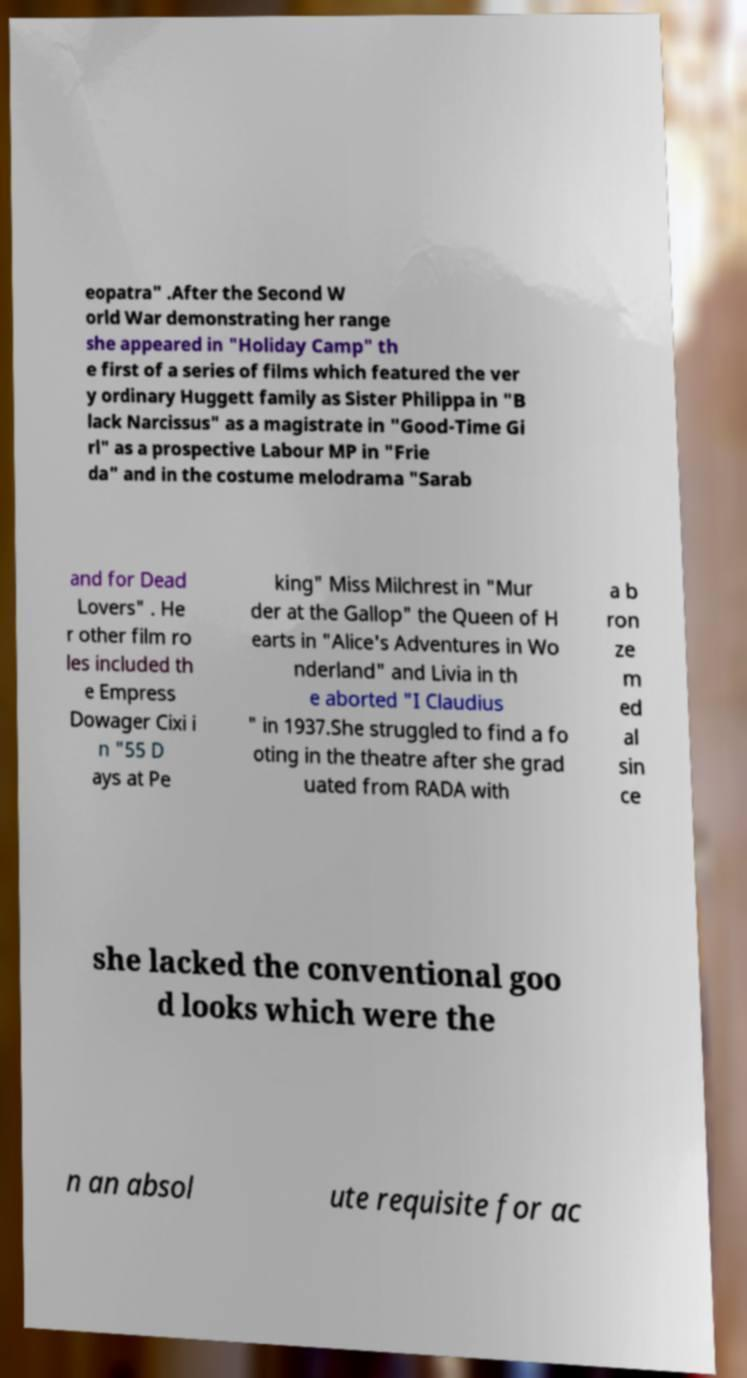Please identify and transcribe the text found in this image. eopatra" .After the Second W orld War demonstrating her range she appeared in "Holiday Camp" th e first of a series of films which featured the ver y ordinary Huggett family as Sister Philippa in "B lack Narcissus" as a magistrate in "Good-Time Gi rl" as a prospective Labour MP in "Frie da" and in the costume melodrama "Sarab and for Dead Lovers" . He r other film ro les included th e Empress Dowager Cixi i n "55 D ays at Pe king" Miss Milchrest in "Mur der at the Gallop" the Queen of H earts in "Alice's Adventures in Wo nderland" and Livia in th e aborted "I Claudius " in 1937.She struggled to find a fo oting in the theatre after she grad uated from RADA with a b ron ze m ed al sin ce she lacked the conventional goo d looks which were the n an absol ute requisite for ac 